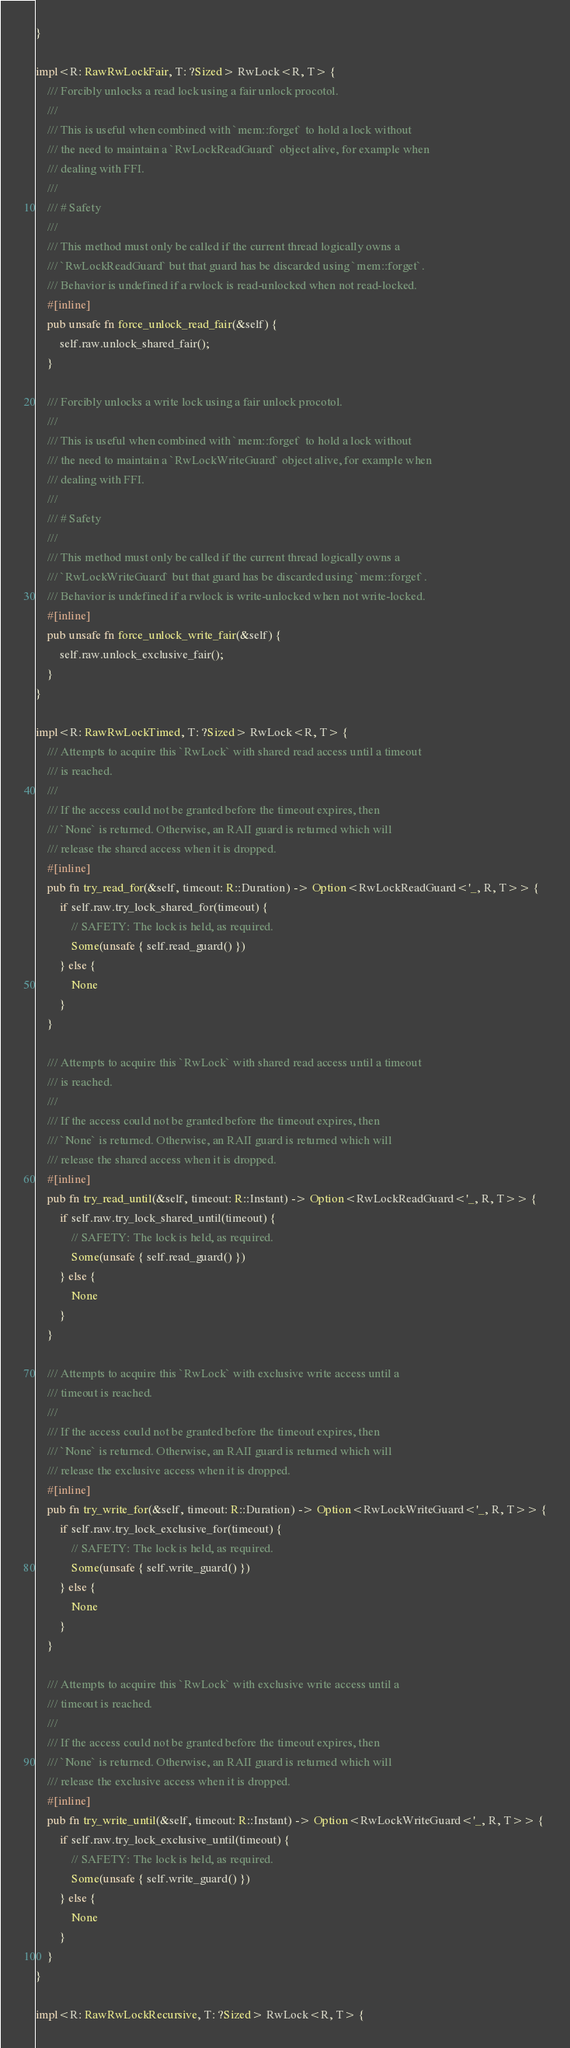Convert code to text. <code><loc_0><loc_0><loc_500><loc_500><_Rust_>}

impl<R: RawRwLockFair, T: ?Sized> RwLock<R, T> {
    /// Forcibly unlocks a read lock using a fair unlock procotol.
    ///
    /// This is useful when combined with `mem::forget` to hold a lock without
    /// the need to maintain a `RwLockReadGuard` object alive, for example when
    /// dealing with FFI.
    ///
    /// # Safety
    ///
    /// This method must only be called if the current thread logically owns a
    /// `RwLockReadGuard` but that guard has be discarded using `mem::forget`.
    /// Behavior is undefined if a rwlock is read-unlocked when not read-locked.
    #[inline]
    pub unsafe fn force_unlock_read_fair(&self) {
        self.raw.unlock_shared_fair();
    }

    /// Forcibly unlocks a write lock using a fair unlock procotol.
    ///
    /// This is useful when combined with `mem::forget` to hold a lock without
    /// the need to maintain a `RwLockWriteGuard` object alive, for example when
    /// dealing with FFI.
    ///
    /// # Safety
    ///
    /// This method must only be called if the current thread logically owns a
    /// `RwLockWriteGuard` but that guard has be discarded using `mem::forget`.
    /// Behavior is undefined if a rwlock is write-unlocked when not write-locked.
    #[inline]
    pub unsafe fn force_unlock_write_fair(&self) {
        self.raw.unlock_exclusive_fair();
    }
}

impl<R: RawRwLockTimed, T: ?Sized> RwLock<R, T> {
    /// Attempts to acquire this `RwLock` with shared read access until a timeout
    /// is reached.
    ///
    /// If the access could not be granted before the timeout expires, then
    /// `None` is returned. Otherwise, an RAII guard is returned which will
    /// release the shared access when it is dropped.
    #[inline]
    pub fn try_read_for(&self, timeout: R::Duration) -> Option<RwLockReadGuard<'_, R, T>> {
        if self.raw.try_lock_shared_for(timeout) {
            // SAFETY: The lock is held, as required.
            Some(unsafe { self.read_guard() })
        } else {
            None
        }
    }

    /// Attempts to acquire this `RwLock` with shared read access until a timeout
    /// is reached.
    ///
    /// If the access could not be granted before the timeout expires, then
    /// `None` is returned. Otherwise, an RAII guard is returned which will
    /// release the shared access when it is dropped.
    #[inline]
    pub fn try_read_until(&self, timeout: R::Instant) -> Option<RwLockReadGuard<'_, R, T>> {
        if self.raw.try_lock_shared_until(timeout) {
            // SAFETY: The lock is held, as required.
            Some(unsafe { self.read_guard() })
        } else {
            None
        }
    }

    /// Attempts to acquire this `RwLock` with exclusive write access until a
    /// timeout is reached.
    ///
    /// If the access could not be granted before the timeout expires, then
    /// `None` is returned. Otherwise, an RAII guard is returned which will
    /// release the exclusive access when it is dropped.
    #[inline]
    pub fn try_write_for(&self, timeout: R::Duration) -> Option<RwLockWriteGuard<'_, R, T>> {
        if self.raw.try_lock_exclusive_for(timeout) {
            // SAFETY: The lock is held, as required.
            Some(unsafe { self.write_guard() })
        } else {
            None
        }
    }

    /// Attempts to acquire this `RwLock` with exclusive write access until a
    /// timeout is reached.
    ///
    /// If the access could not be granted before the timeout expires, then
    /// `None` is returned. Otherwise, an RAII guard is returned which will
    /// release the exclusive access when it is dropped.
    #[inline]
    pub fn try_write_until(&self, timeout: R::Instant) -> Option<RwLockWriteGuard<'_, R, T>> {
        if self.raw.try_lock_exclusive_until(timeout) {
            // SAFETY: The lock is held, as required.
            Some(unsafe { self.write_guard() })
        } else {
            None
        }
    }
}

impl<R: RawRwLockRecursive, T: ?Sized> RwLock<R, T> {</code> 